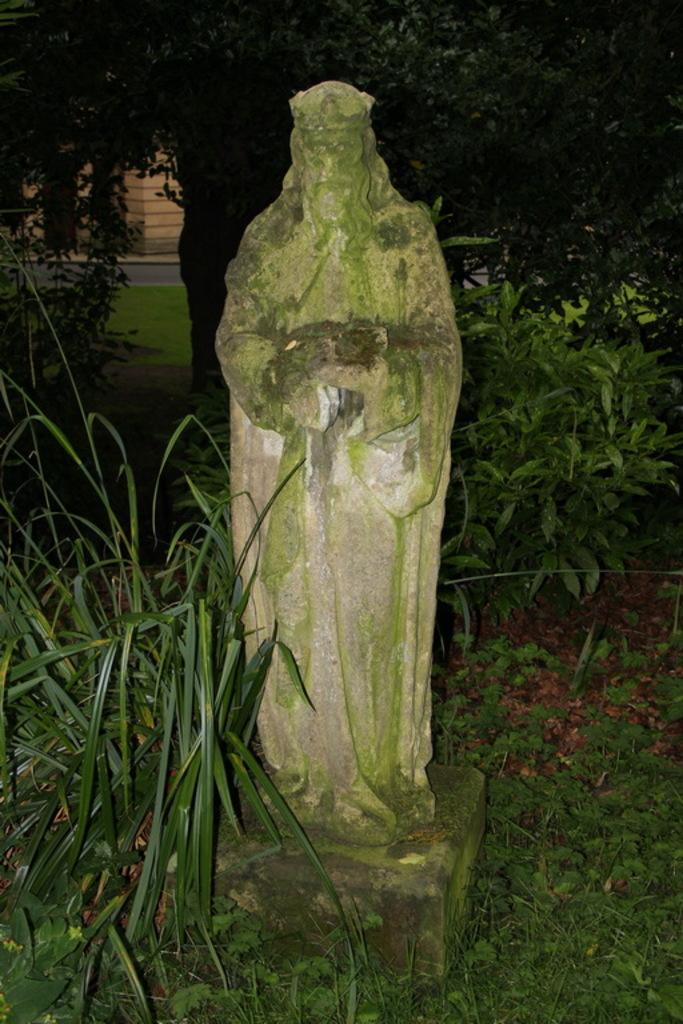What is the main subject of the image? There is a sculpture of a person in the image. Can you describe the surroundings of the sculpture? There is a lot of greenery around the sculpture. What type of berry is growing on the sculpture in the image? There are no berries present on the sculpture in the image. 